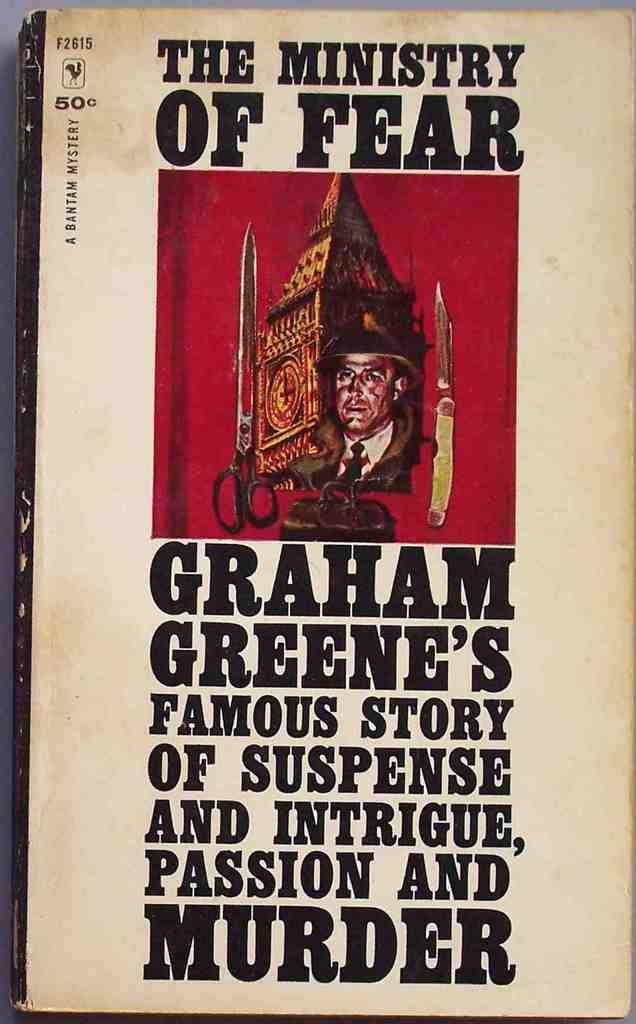<image>
Relay a brief, clear account of the picture shown. A worn paperback of a Graham Greene book. 